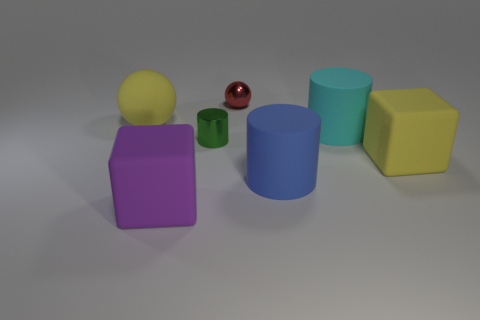What color is the shiny ball?
Offer a terse response. Red. What is the sphere behind the big yellow ball made of?
Ensure brevity in your answer.  Metal. There is a cyan object; is its shape the same as the yellow object that is left of the purple rubber block?
Keep it short and to the point. No. Are there more red spheres than yellow shiny cubes?
Make the answer very short. Yes. Is there anything else that is the same color as the rubber sphere?
Offer a terse response. Yes. What shape is the big cyan object that is the same material as the large blue cylinder?
Your response must be concise. Cylinder. There is a big cylinder that is in front of the shiny thing to the left of the tiny metallic sphere; what is its material?
Offer a very short reply. Rubber. There is a small object that is on the left side of the tiny red metal sphere; is it the same shape as the cyan thing?
Your answer should be compact. Yes. Are there more small things in front of the purple block than tiny green objects?
Make the answer very short. No. Are there any other things that are the same material as the large ball?
Your answer should be very brief. Yes. 